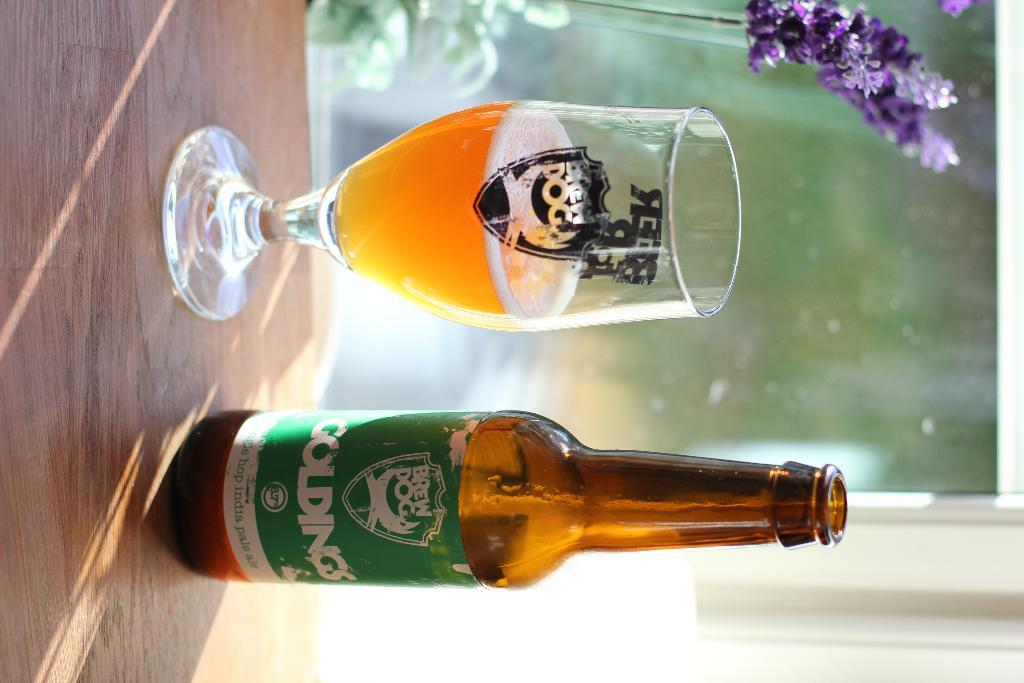<image>
Describe the image concisely. a bottle of beer called Goldings next to a glass of same. 